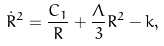Convert formula to latex. <formula><loc_0><loc_0><loc_500><loc_500>\dot { R } ^ { 2 } = \frac { C _ { 1 } } { R } + \frac { \Lambda } { 3 } R ^ { 2 } - k ,</formula> 